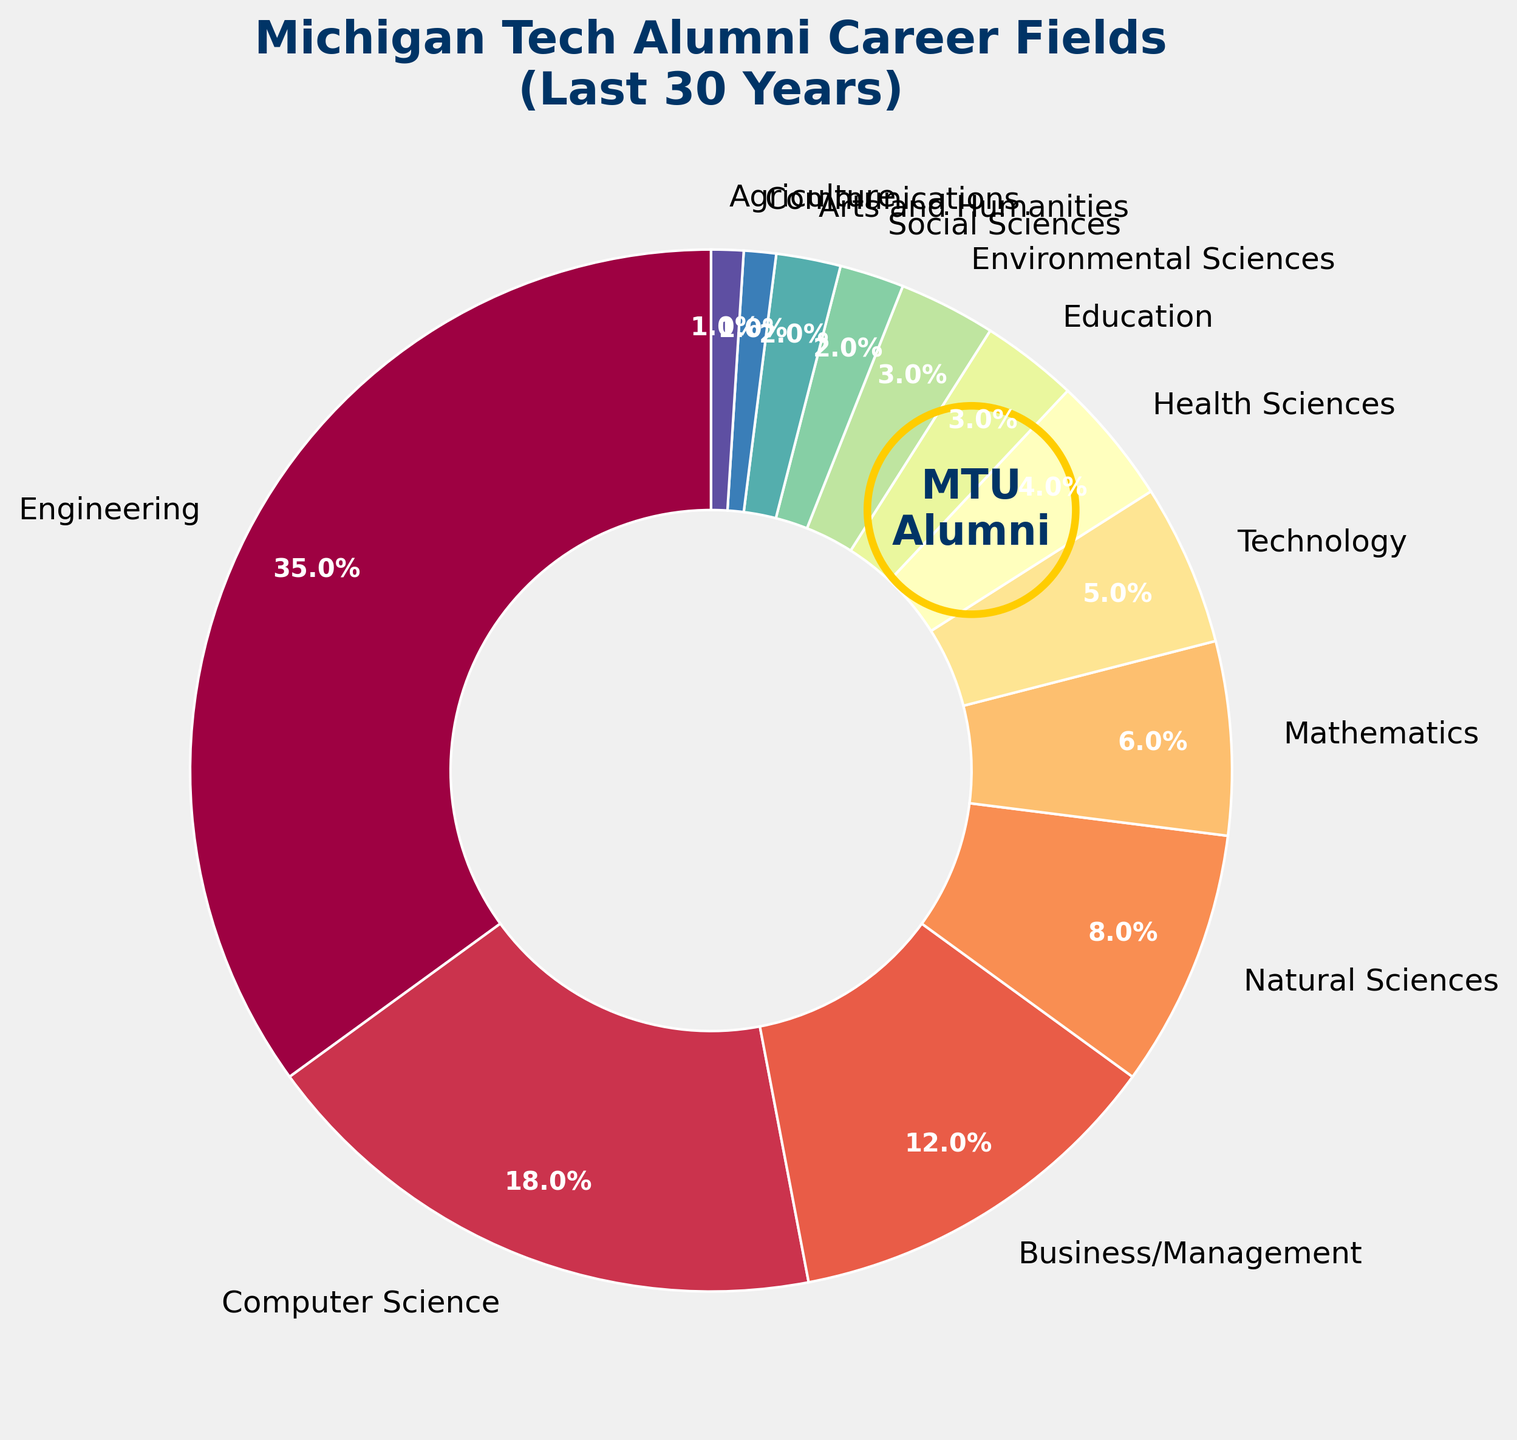What is the most common career field for Michigan Tech alumni according to the figure? The figure shows that the 'Engineering' slice is the largest, indicating it is the most common career field.
Answer: Engineering Which two career fields have the smallest representation among Michigan Tech alumni? The figure shows that 'Communications' and 'Agriculture' each have the smallest slices, both labeled with 1%.
Answer: Communications and Agriculture How does the percentage of graduates in 'Business/Management' compare to those in 'Natural Sciences'? The figure shows that 'Business/Management' has a 12% share, whereas 'Natural Sciences' has 8%. Thus, 'Business/Management' is greater by 4%.
Answer: Business/Management is 4% greater than Natural Sciences Which career fields have a combined percentage greater than that of 'Engineering' alone? Summing the percentages of 'Computer Science' (18%) and 'Business/Management' (12%) yields 30%. Adding 'Natural Sciences' (8%), 'Mathematics' (6%), and 'Technology' (5%) provides a total of 41%, which is greater than the 35% for 'Engineering'.
Answer: Combined total of Computer Science, Business/Management, Natural Sciences, Mathematics, and Technology What's the combined percentage of graduates in 'Health Sciences' and 'Education'? Adding the percentages from the figure, 'Health Sciences' (4%) and 'Education' (3%) yields: 4% + 3% = 7%.
Answer: 7% Which career field is represented by a slice smaller than that of 'Mathematics' but larger than 'Social Sciences'? The figure shows 'Technology' at 5%, which is less than 'Mathematics' at 6% but more than 'Social Sciences' at 2%.
Answer: Technology How many career fields have a representation of 4% or less? The career fields with 4% or less are 'Health Sciences' (4%), 'Education' (3%), 'Environmental Sciences' (3%), 'Social Sciences' (2%), 'Arts and Humanities' (2%), 'Communications' (1%), and 'Agriculture' (1%). Counting these fields gives 7.
Answer: 7 Which field has a larger percentage, 'Environmental Sciences' or 'Arts and Humanities'? The figure shows 'Environmental Sciences' and 'Arts and Humanities' as equal at 3% and 2% respectively, thus 'Environmental Sciences' is larger by 1%.
Answer: Environmental Sciences What is the total percentage of all career fields except 'Engineering' and 'Computer Science'? Summing the percentages of all other fields: 12% (Business/Management) + 8% (Natural Sciences) + 6% (Mathematics) + 5% (Technology) + 4% (Health Sciences) + 3% (Education) + 3% (Environmental Sciences) + 2% (Social Sciences) + 2% (Arts and Humanities) + 1% (Communications) + 1% (Agriculture) gives 47%.
Answer: 47% What color is the slice representing 'Technology'? Referring to the visual attributes in the pie chart, the slice for 'Technology' is shown with a color toward the middle of the color gradient used, which is identifiable.
Answer: Mid-spectrum color 